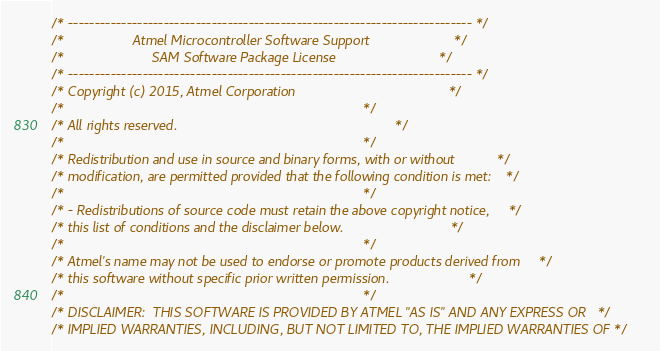<code> <loc_0><loc_0><loc_500><loc_500><_C_>/* ---------------------------------------------------------------------------- */
/*                  Atmel Microcontroller Software Support                      */
/*                       SAM Software Package License                           */
/* ---------------------------------------------------------------------------- */
/* Copyright (c) 2015, Atmel Corporation                                        */
/*                                                                              */
/* All rights reserved.                                                         */
/*                                                                              */
/* Redistribution and use in source and binary forms, with or without           */
/* modification, are permitted provided that the following condition is met:    */
/*                                                                              */
/* - Redistributions of source code must retain the above copyright notice,     */
/* this list of conditions and the disclaimer below.                            */
/*                                                                              */
/* Atmel's name may not be used to endorse or promote products derived from     */
/* this software without specific prior written permission.                     */
/*                                                                              */
/* DISCLAIMER:  THIS SOFTWARE IS PROVIDED BY ATMEL "AS IS" AND ANY EXPRESS OR   */
/* IMPLIED WARRANTIES, INCLUDING, BUT NOT LIMITED TO, THE IMPLIED WARRANTIES OF */</code> 